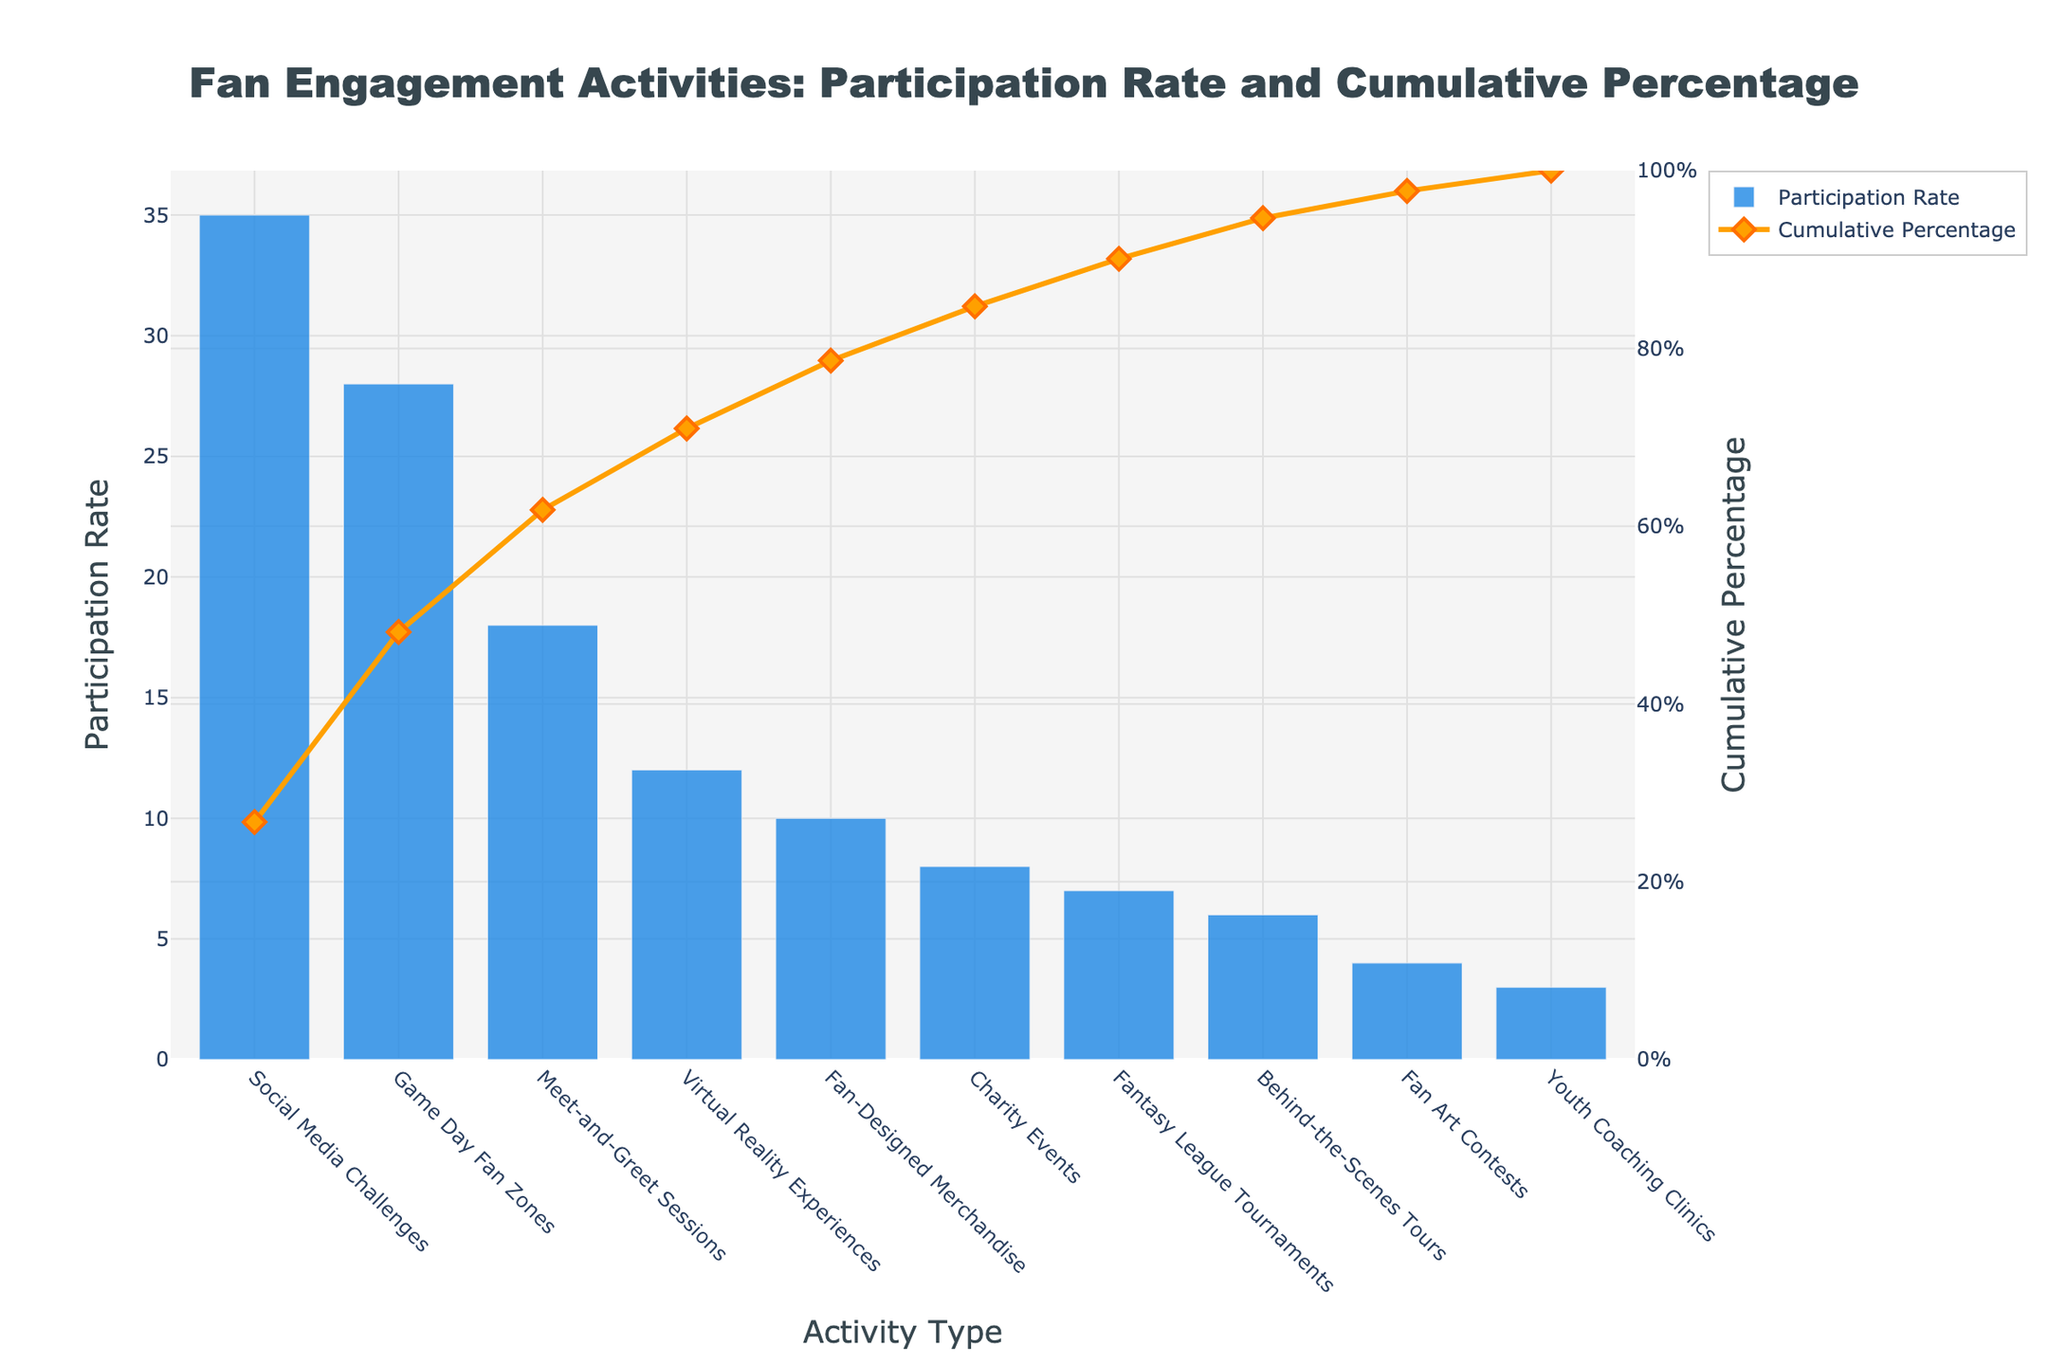Which activity type has the highest participation rate? The highest bar in the chart represents the activity with the highest participation rate.
Answer: Social Media Challenges How many activities have a participation rate above 20%? Count the bars that exceed the 20% mark on the y-axis for Participation Rate.
Answer: 2 What's the cumulative percentage for Game Day Fan Zones? Locate the plot point for Game Day Fan Zones on the Cumulative Percentage line and read the y2-axis value.
Answer: 63% What's the difference in participation rate between Social Media Challenges and Fan-Designed Merchandise? Subtract the Participation Rate of Fan-Designed Merchandise from that of Social Media Challenges (35 - 10).
Answer: 25% Which activity is responsible for surpassing the 50% cumulative percentage point? Find the first activity where the Cumulative Percentage line surpasses 50%. This occurs just after adding the participation rate of Game Day Fan Zones (35 + 28), which is over 50%.
Answer: Game Day Fan Zones What is the cumulative percentage after including Meet-and-Greet Sessions? Add the participation rates of Social Media Challenges, Game Day Fan Zones, and Meet-and-Greet Sessions to determine their cumulative percentage (35 + 28 + 18). Then, convert this sum to a percentage of the total, which the chart indicates directly.
Answer: 81% How does the cumulative percentage change between Virtual Reality Experiences and Fan-Designed Merchandise? Find the y2-axis value difference between Virtual Reality Experiences (4th point) and Fan-Designed Merchandise (5th point) on the Cumulative Percentage line. The cumulative percentage for Virtual Reality Experiences is about 93% and for Fan-Designed Merchandise is about 100%.
Answer: 7% Which activity type has a lower participation rate: Fantasy League Tournaments or Charity Events? Compare the heights of the bars for Fantasy League Tournaments and Charity Events.
Answer: Fantasy League Tournaments What is the cumulative percentage for the combined participation rates of the bottom five activity types? Add the participation rates of the bottom five activities (10 + 8 + 7 + 6 + 4 + 3), then find what percentage of the total this sum represents. The chart directly indicates it cumulatively.
Answer: 100% What are the colors used for the Participation Rate and the Cumulative Percentage lines? Identify the colors of the bar and line. The Participation Rate bars are blue and the Cumulative Percentage line is orange.
Answer: blue and orange 